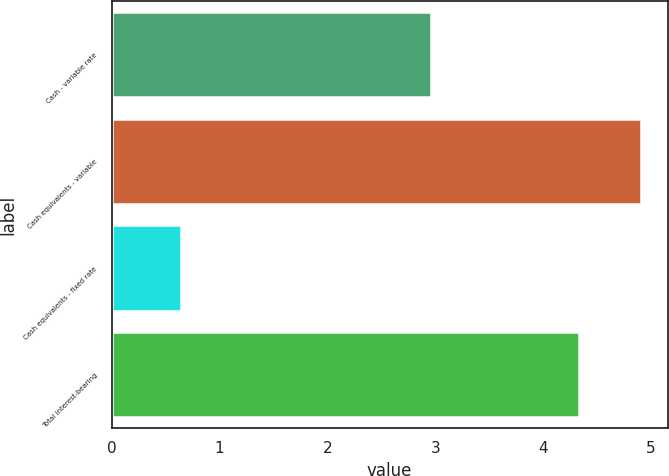Convert chart to OTSL. <chart><loc_0><loc_0><loc_500><loc_500><bar_chart><fcel>Cash - variable rate<fcel>Cash equivalents - variable<fcel>Cash equivalents - fixed rate<fcel>Total interest-bearing<nl><fcel>2.96<fcel>4.91<fcel>0.64<fcel>4.33<nl></chart> 